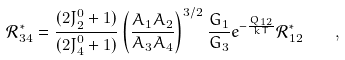Convert formula to latex. <formula><loc_0><loc_0><loc_500><loc_500>\mathcal { R } ^ { * } _ { 3 4 } = \frac { ( 2 J ^ { 0 } _ { 2 } + 1 ) } { ( 2 J ^ { 0 } _ { 4 } + 1 ) } \left ( \frac { A _ { 1 } A _ { 2 } } { A _ { 3 } A _ { 4 } } \right ) ^ { 3 / 2 } \frac { G _ { 1 } } { G _ { 3 } } e ^ { - \frac { Q _ { 1 2 } } { k T } } \mathcal { R } ^ { * } _ { 1 2 } \quad ,</formula> 